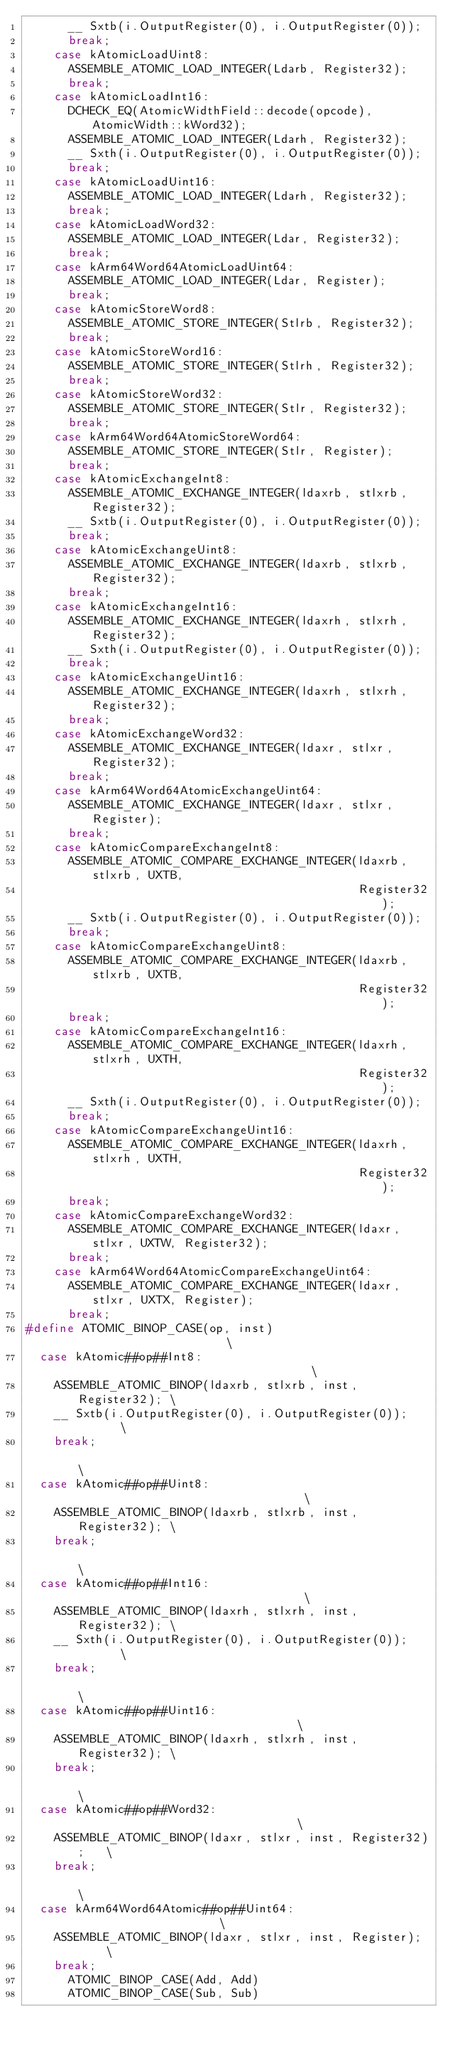Convert code to text. <code><loc_0><loc_0><loc_500><loc_500><_C++_>      __ Sxtb(i.OutputRegister(0), i.OutputRegister(0));
      break;
    case kAtomicLoadUint8:
      ASSEMBLE_ATOMIC_LOAD_INTEGER(Ldarb, Register32);
      break;
    case kAtomicLoadInt16:
      DCHECK_EQ(AtomicWidthField::decode(opcode), AtomicWidth::kWord32);
      ASSEMBLE_ATOMIC_LOAD_INTEGER(Ldarh, Register32);
      __ Sxth(i.OutputRegister(0), i.OutputRegister(0));
      break;
    case kAtomicLoadUint16:
      ASSEMBLE_ATOMIC_LOAD_INTEGER(Ldarh, Register32);
      break;
    case kAtomicLoadWord32:
      ASSEMBLE_ATOMIC_LOAD_INTEGER(Ldar, Register32);
      break;
    case kArm64Word64AtomicLoadUint64:
      ASSEMBLE_ATOMIC_LOAD_INTEGER(Ldar, Register);
      break;
    case kAtomicStoreWord8:
      ASSEMBLE_ATOMIC_STORE_INTEGER(Stlrb, Register32);
      break;
    case kAtomicStoreWord16:
      ASSEMBLE_ATOMIC_STORE_INTEGER(Stlrh, Register32);
      break;
    case kAtomicStoreWord32:
      ASSEMBLE_ATOMIC_STORE_INTEGER(Stlr, Register32);
      break;
    case kArm64Word64AtomicStoreWord64:
      ASSEMBLE_ATOMIC_STORE_INTEGER(Stlr, Register);
      break;
    case kAtomicExchangeInt8:
      ASSEMBLE_ATOMIC_EXCHANGE_INTEGER(ldaxrb, stlxrb, Register32);
      __ Sxtb(i.OutputRegister(0), i.OutputRegister(0));
      break;
    case kAtomicExchangeUint8:
      ASSEMBLE_ATOMIC_EXCHANGE_INTEGER(ldaxrb, stlxrb, Register32);
      break;
    case kAtomicExchangeInt16:
      ASSEMBLE_ATOMIC_EXCHANGE_INTEGER(ldaxrh, stlxrh, Register32);
      __ Sxth(i.OutputRegister(0), i.OutputRegister(0));
      break;
    case kAtomicExchangeUint16:
      ASSEMBLE_ATOMIC_EXCHANGE_INTEGER(ldaxrh, stlxrh, Register32);
      break;
    case kAtomicExchangeWord32:
      ASSEMBLE_ATOMIC_EXCHANGE_INTEGER(ldaxr, stlxr, Register32);
      break;
    case kArm64Word64AtomicExchangeUint64:
      ASSEMBLE_ATOMIC_EXCHANGE_INTEGER(ldaxr, stlxr, Register);
      break;
    case kAtomicCompareExchangeInt8:
      ASSEMBLE_ATOMIC_COMPARE_EXCHANGE_INTEGER(ldaxrb, stlxrb, UXTB,
                                               Register32);
      __ Sxtb(i.OutputRegister(0), i.OutputRegister(0));
      break;
    case kAtomicCompareExchangeUint8:
      ASSEMBLE_ATOMIC_COMPARE_EXCHANGE_INTEGER(ldaxrb, stlxrb, UXTB,
                                               Register32);
      break;
    case kAtomicCompareExchangeInt16:
      ASSEMBLE_ATOMIC_COMPARE_EXCHANGE_INTEGER(ldaxrh, stlxrh, UXTH,
                                               Register32);
      __ Sxth(i.OutputRegister(0), i.OutputRegister(0));
      break;
    case kAtomicCompareExchangeUint16:
      ASSEMBLE_ATOMIC_COMPARE_EXCHANGE_INTEGER(ldaxrh, stlxrh, UXTH,
                                               Register32);
      break;
    case kAtomicCompareExchangeWord32:
      ASSEMBLE_ATOMIC_COMPARE_EXCHANGE_INTEGER(ldaxr, stlxr, UXTW, Register32);
      break;
    case kArm64Word64AtomicCompareExchangeUint64:
      ASSEMBLE_ATOMIC_COMPARE_EXCHANGE_INTEGER(ldaxr, stlxr, UXTX, Register);
      break;
#define ATOMIC_BINOP_CASE(op, inst)                          \
  case kAtomic##op##Int8:                                    \
    ASSEMBLE_ATOMIC_BINOP(ldaxrb, stlxrb, inst, Register32); \
    __ Sxtb(i.OutputRegister(0), i.OutputRegister(0));       \
    break;                                                   \
  case kAtomic##op##Uint8:                                   \
    ASSEMBLE_ATOMIC_BINOP(ldaxrb, stlxrb, inst, Register32); \
    break;                                                   \
  case kAtomic##op##Int16:                                   \
    ASSEMBLE_ATOMIC_BINOP(ldaxrh, stlxrh, inst, Register32); \
    __ Sxth(i.OutputRegister(0), i.OutputRegister(0));       \
    break;                                                   \
  case kAtomic##op##Uint16:                                  \
    ASSEMBLE_ATOMIC_BINOP(ldaxrh, stlxrh, inst, Register32); \
    break;                                                   \
  case kAtomic##op##Word32:                                  \
    ASSEMBLE_ATOMIC_BINOP(ldaxr, stlxr, inst, Register32);   \
    break;                                                   \
  case kArm64Word64Atomic##op##Uint64:                       \
    ASSEMBLE_ATOMIC_BINOP(ldaxr, stlxr, inst, Register);     \
    break;
      ATOMIC_BINOP_CASE(Add, Add)
      ATOMIC_BINOP_CASE(Sub, Sub)</code> 